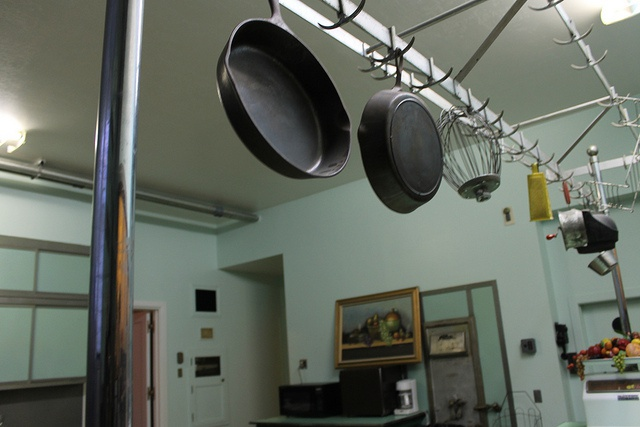Describe the objects in this image and their specific colors. I can see microwave in black and gray tones, apple in gray, black, maroon, and brown tones, orange in gray, maroon, black, brown, and salmon tones, orange in gray, olive, darkgreen, and black tones, and apple in gray, maroon, and black tones in this image. 